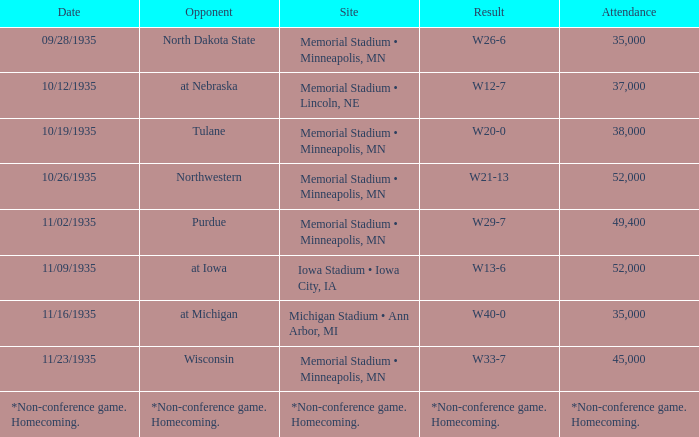What is the count of attendees at the game where the result was w29-7? 49400.0. 